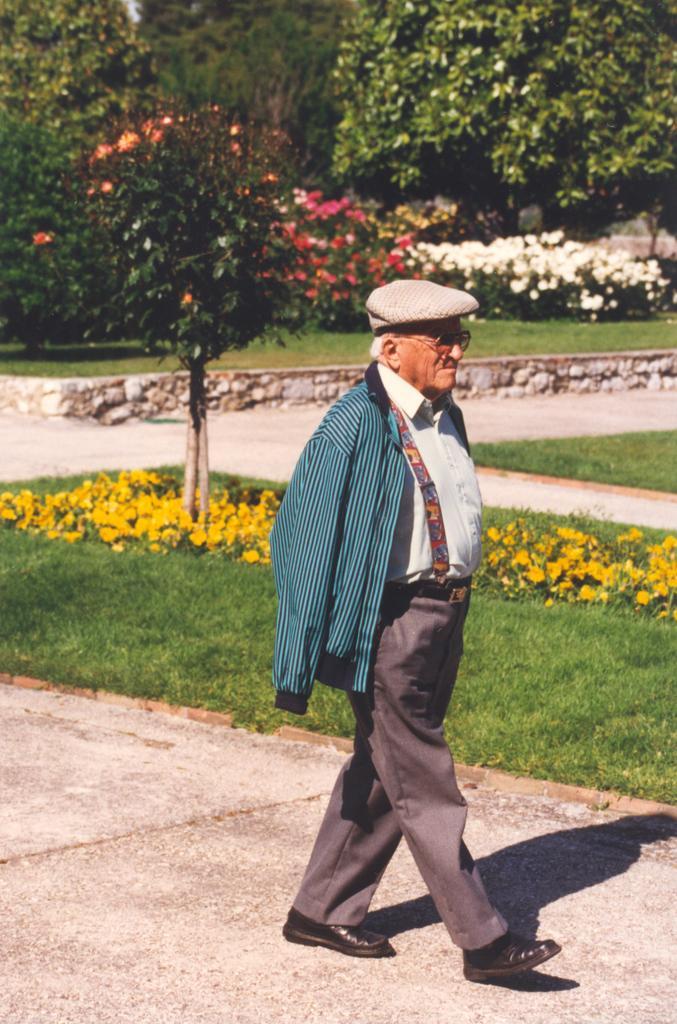Could you give a brief overview of what you see in this image? In the picture I can see an old man wearing jacket, shirt, pants, shoes, hat and spectacles is walking on the road. In the background, we can see the grass, plants, flowers and trees. 